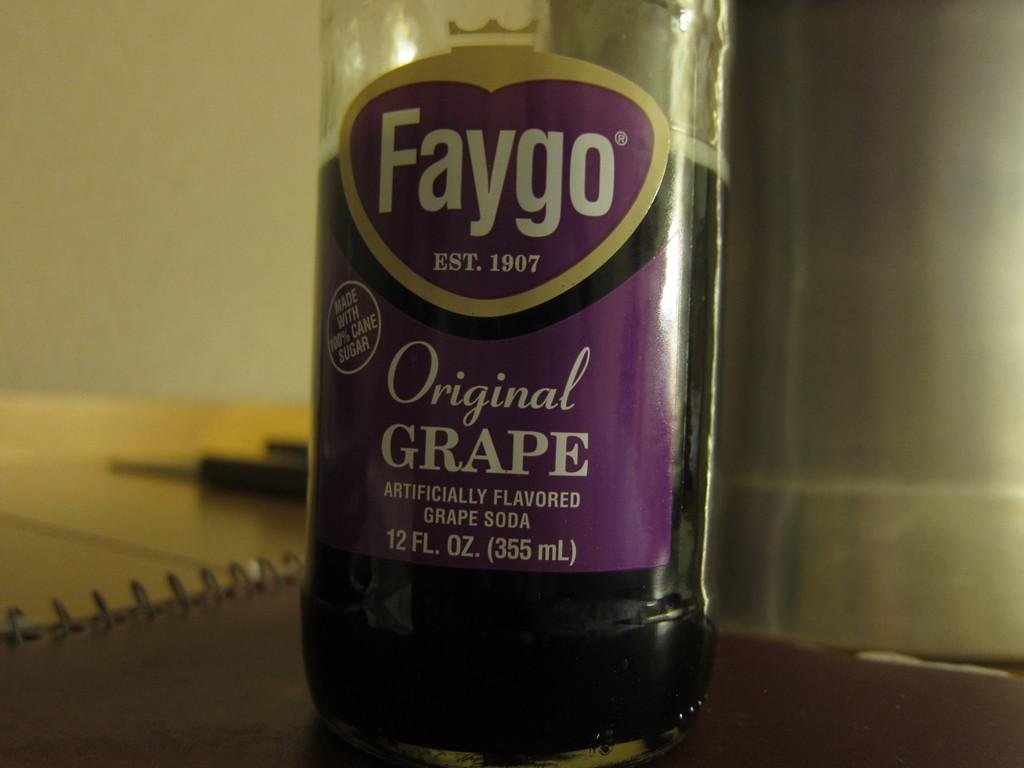How long has this brand of grape soda been around?
Provide a succinct answer. 1907. 